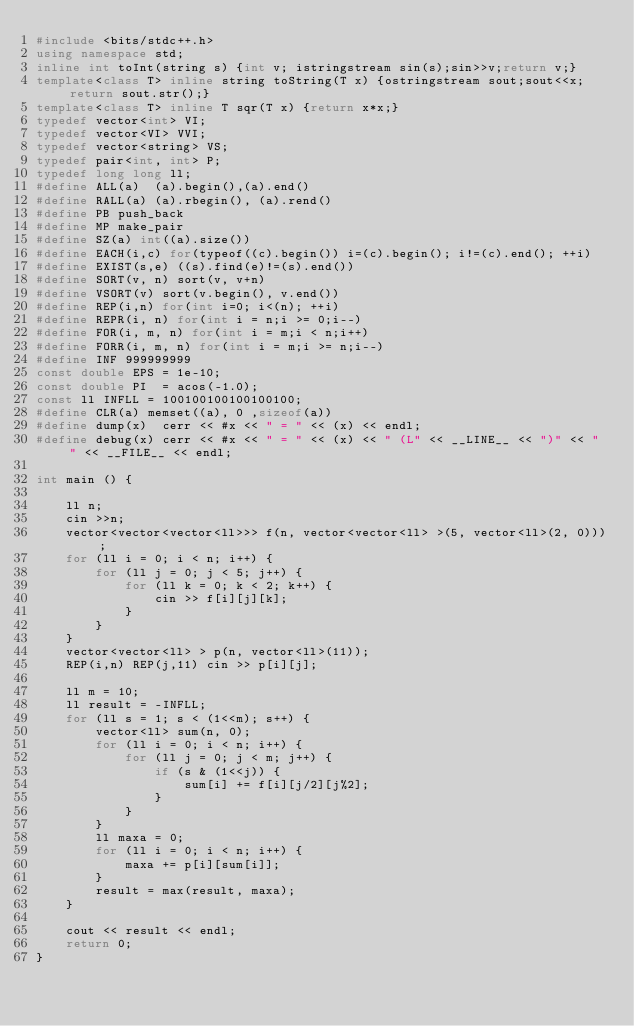<code> <loc_0><loc_0><loc_500><loc_500><_C++_>#include <bits/stdc++.h>
using namespace std;
inline int toInt(string s) {int v; istringstream sin(s);sin>>v;return v;}
template<class T> inline string toString(T x) {ostringstream sout;sout<<x;return sout.str();}
template<class T> inline T sqr(T x) {return x*x;}
typedef vector<int> VI;
typedef vector<VI> VVI;
typedef vector<string> VS;
typedef pair<int, int> P;
typedef long long ll;
#define ALL(a)  (a).begin(),(a).end()
#define RALL(a) (a).rbegin(), (a).rend()
#define PB push_back
#define MP make_pair
#define SZ(a) int((a).size())
#define EACH(i,c) for(typeof((c).begin()) i=(c).begin(); i!=(c).end(); ++i)
#define EXIST(s,e) ((s).find(e)!=(s).end())
#define SORT(v, n) sort(v, v+n)
#define VSORT(v) sort(v.begin(), v.end())
#define REP(i,n) for(int i=0; i<(n); ++i)
#define REPR(i, n) for(int i = n;i >= 0;i--)
#define FOR(i, m, n) for(int i = m;i < n;i++)
#define FORR(i, m, n) for(int i = m;i >= n;i--)
#define INF 999999999
const double EPS = 1e-10;
const double PI  = acos(-1.0);
const ll INFLL = 100100100100100100;
#define CLR(a) memset((a), 0 ,sizeof(a))
#define dump(x)  cerr << #x << " = " << (x) << endl;
#define debug(x) cerr << #x << " = " << (x) << " (L" << __LINE__ << ")" << " " << __FILE__ << endl;

int main () {
    
    ll n;
    cin >>n;
    vector<vector<vector<ll>>> f(n, vector<vector<ll> >(5, vector<ll>(2, 0)));
    for (ll i = 0; i < n; i++) {
        for (ll j = 0; j < 5; j++) {
            for (ll k = 0; k < 2; k++) {
                cin >> f[i][j][k];
            }
        }
    }
    vector<vector<ll> > p(n, vector<ll>(11));
    REP(i,n) REP(j,11) cin >> p[i][j];
    
    ll m = 10;
    ll result = -INFLL;
    for (ll s = 1; s < (1<<m); s++) {
        vector<ll> sum(n, 0);
        for (ll i = 0; i < n; i++) {
            for (ll j = 0; j < m; j++) {
                if (s & (1<<j)) {
                    sum[i] += f[i][j/2][j%2];
                }
            }
        }
        ll maxa = 0;
        for (ll i = 0; i < n; i++) {
            maxa += p[i][sum[i]];
        }
        result = max(result, maxa);
    }
    
    cout << result << endl;
    return 0;
}
</code> 